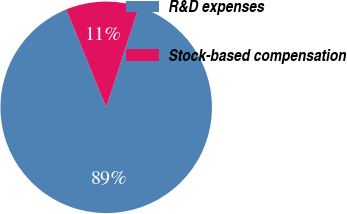<chart> <loc_0><loc_0><loc_500><loc_500><pie_chart><fcel>R&D expenses<fcel>Stock-based compensation<nl><fcel>88.83%<fcel>11.17%<nl></chart> 